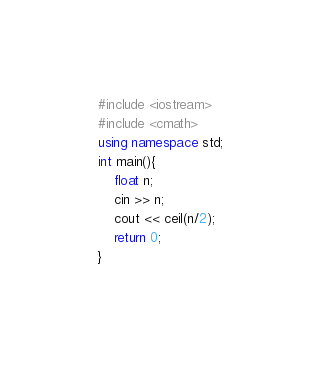<code> <loc_0><loc_0><loc_500><loc_500><_C++_>#include <iostream>
#include <cmath>
using namespace std;
int main(){
    float n;
    cin >> n;
    cout << ceil(n/2);
    return 0;
}</code> 